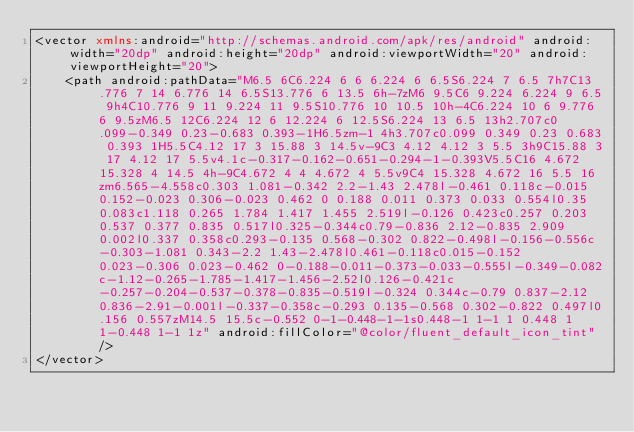<code> <loc_0><loc_0><loc_500><loc_500><_XML_><vector xmlns:android="http://schemas.android.com/apk/res/android" android:width="20dp" android:height="20dp" android:viewportWidth="20" android:viewportHeight="20">
    <path android:pathData="M6.5 6C6.224 6 6 6.224 6 6.5S6.224 7 6.5 7h7C13.776 7 14 6.776 14 6.5S13.776 6 13.5 6h-7zM6 9.5C6 9.224 6.224 9 6.5 9h4C10.776 9 11 9.224 11 9.5S10.776 10 10.5 10h-4C6.224 10 6 9.776 6 9.5zM6.5 12C6.224 12 6 12.224 6 12.5S6.224 13 6.5 13h2.707c0.099-0.349 0.23-0.683 0.393-1H6.5zm-1 4h3.707c0.099 0.349 0.23 0.683 0.393 1H5.5C4.12 17 3 15.88 3 14.5v-9C3 4.12 4.12 3 5.5 3h9C15.88 3 17 4.12 17 5.5v4.1c-0.317-0.162-0.651-0.294-1-0.393V5.5C16 4.672 15.328 4 14.5 4h-9C4.672 4 4 4.672 4 5.5v9C4 15.328 4.672 16 5.5 16zm6.565-4.558c0.303 1.081-0.342 2.2-1.43 2.478l-0.461 0.118c-0.015 0.152-0.023 0.306-0.023 0.462 0 0.188 0.011 0.373 0.033 0.554l0.35 0.083c1.118 0.265 1.784 1.417 1.455 2.519l-0.126 0.423c0.257 0.203 0.537 0.377 0.835 0.517l0.325-0.344c0.79-0.836 2.12-0.835 2.909 0.002l0.337 0.358c0.293-0.135 0.568-0.302 0.822-0.498l-0.156-0.556c-0.303-1.081 0.343-2.2 1.43-2.478l0.461-0.118c0.015-0.152 0.023-0.306 0.023-0.462 0-0.188-0.011-0.373-0.033-0.555l-0.349-0.082c-1.12-0.265-1.785-1.417-1.456-2.52l0.126-0.421c-0.257-0.204-0.537-0.378-0.835-0.519l-0.324 0.344c-0.79 0.837-2.12 0.836-2.91-0.001l-0.337-0.358c-0.293 0.135-0.568 0.302-0.822 0.497l0.156 0.557zM14.5 15.5c-0.552 0-1-0.448-1-1s0.448-1 1-1 1 0.448 1 1-0.448 1-1 1z" android:fillColor="@color/fluent_default_icon_tint"/>
</vector>
</code> 